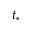Convert formula to latex. <formula><loc_0><loc_0><loc_500><loc_500>t _ { * }</formula> 